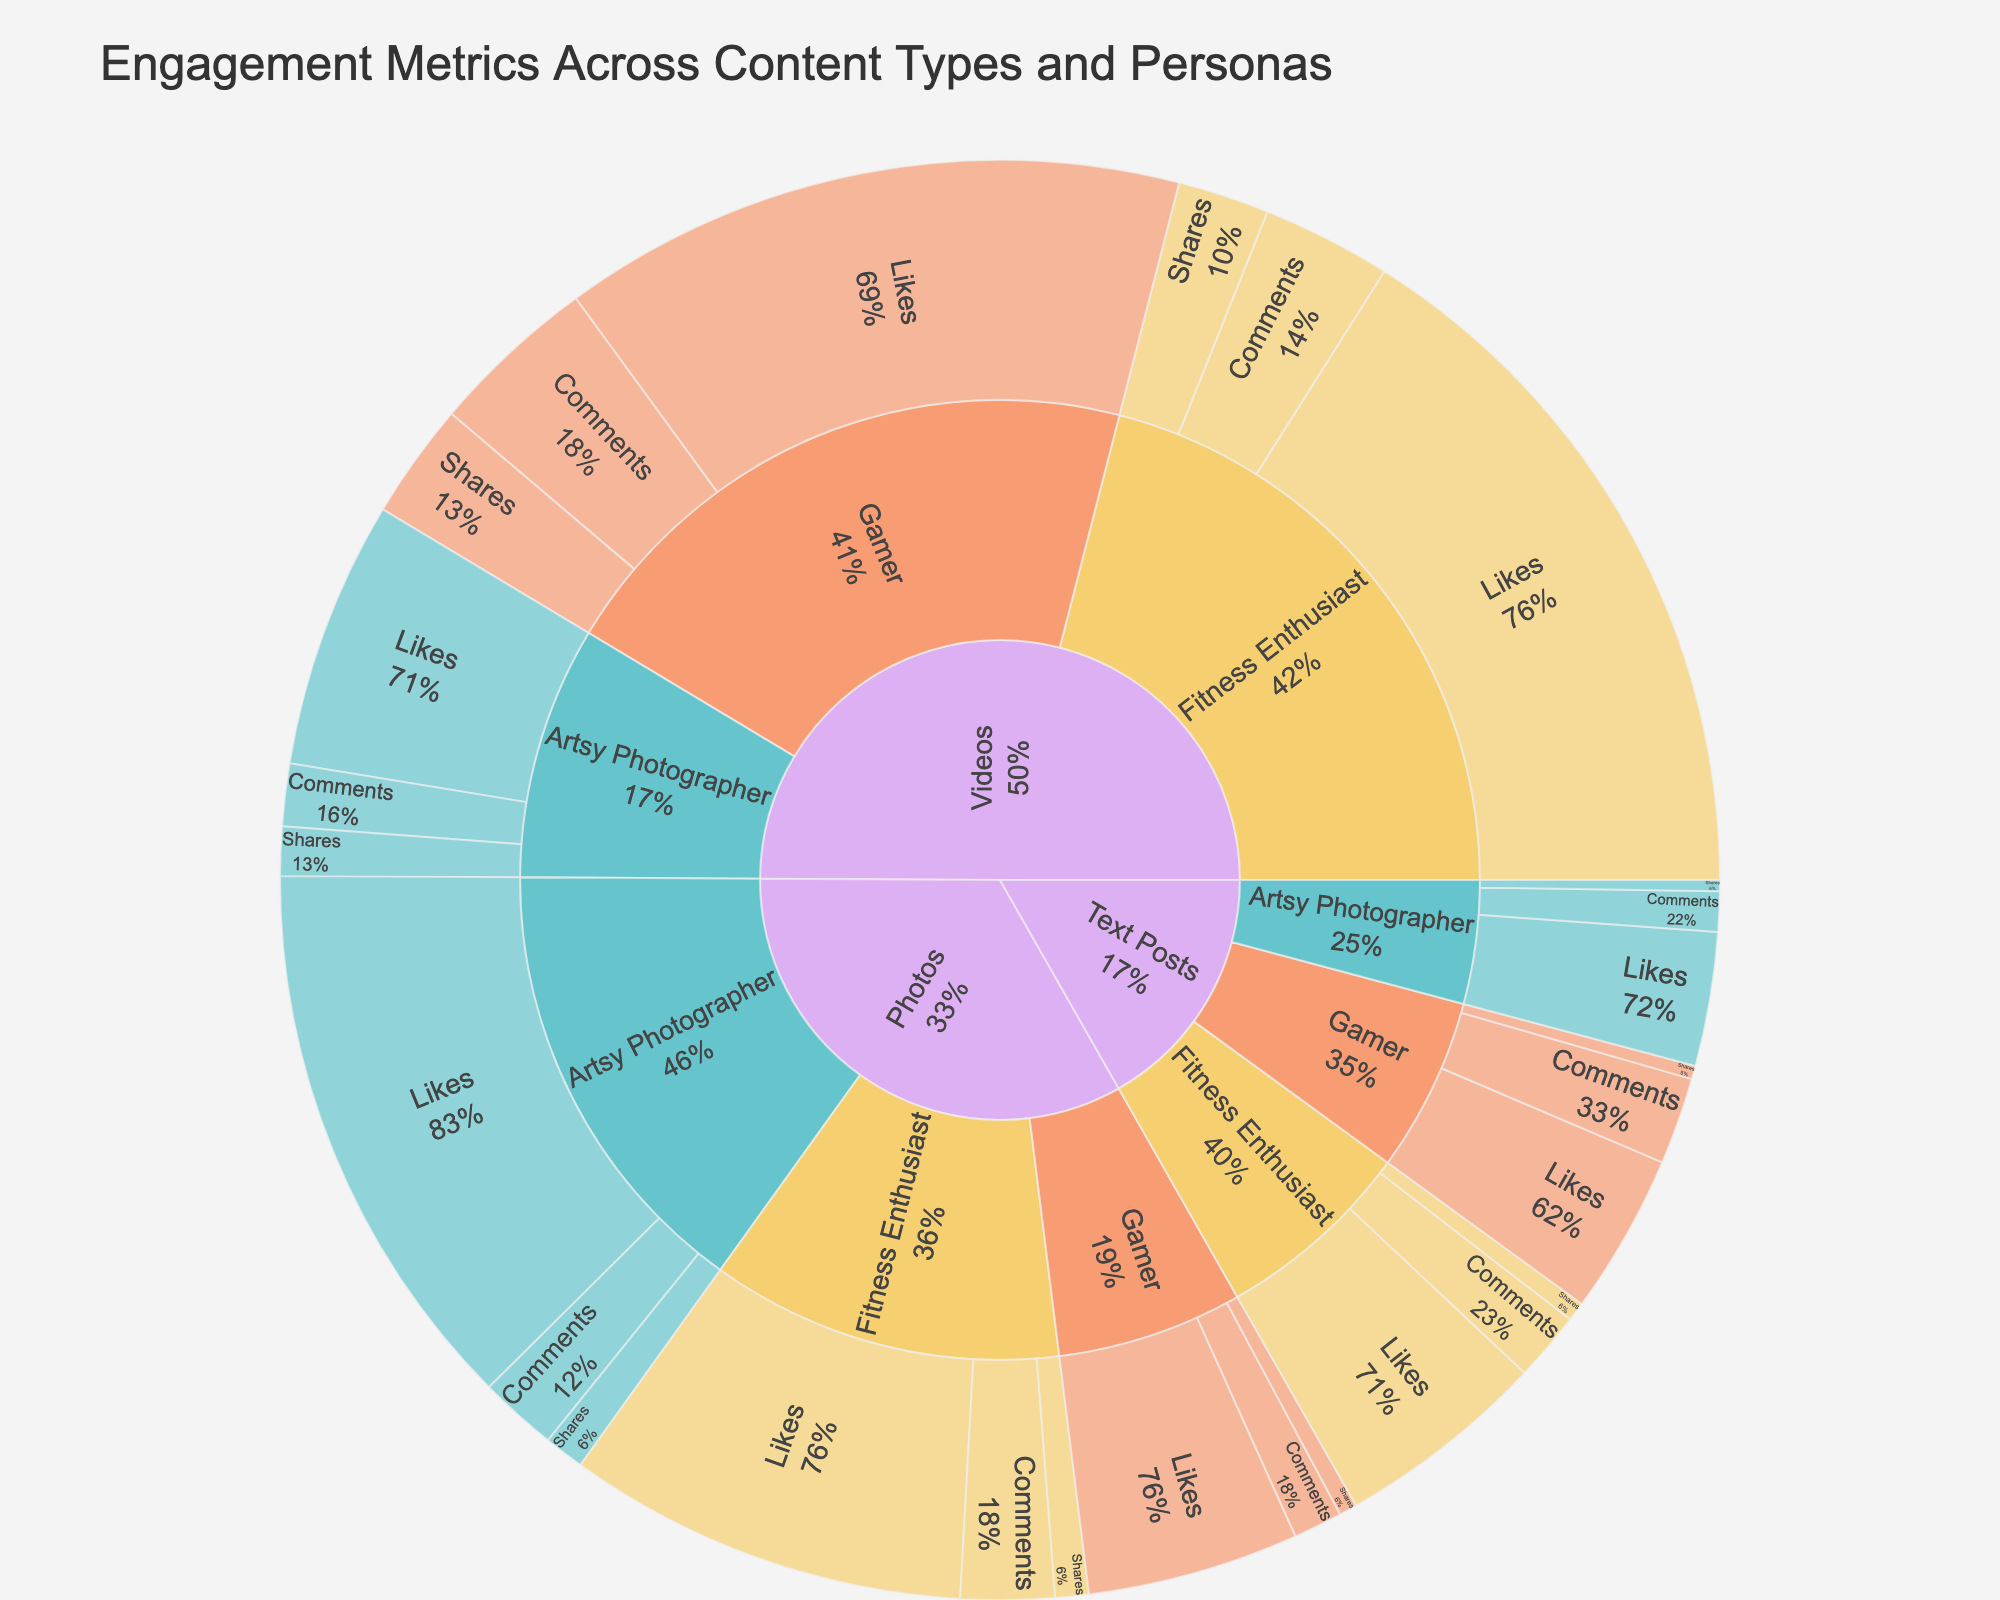What is the total number of engagement metrics for Photos as an Artsy Photographer? To find the total, sum the likes, comments, and shares for Photos as an Artsy Photographer: 2500 (likes) + 350 (comments) + 180 (shares) = 3030.
Answer: 3030 Which persona received the highest number of likes for Videos? Compare the number of likes for Videos across all personas: 1200 (Artsy Photographer), 3200 (Fitness Enthusiast), and 2800 (Gamer). The highest is for Fitness Enthusiast, with 3200 likes.
Answer: Fitness Enthusiast How do the shares for Text Posts by the Fitness Enthusiast compare to those by the Gamer? Look at the shares for Text Posts by each persona: 85 (Fitness Enthusiast) versus 60 (Gamer). 85 is greater than 60.
Answer: Fitness Enthusiast has higher shares What is the percentage share of Likes for the Gamer in the Photos content type? The total number of likes for Photos is the sum across all personas: 2500 (Artsy Photographer) + 1800 (Fitness Enthusiast) + 950 (Gamer) = 5250.
The percentage share of the Gamer is (950 / 5250) * 100 ≈ 18.1%.
Answer: 18.1% 